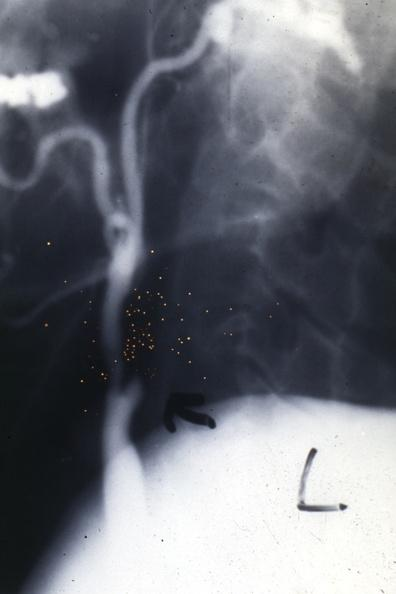does acute lymphocytic leukemia show carotid sclerosing panarteritis?
Answer the question using a single word or phrase. No 